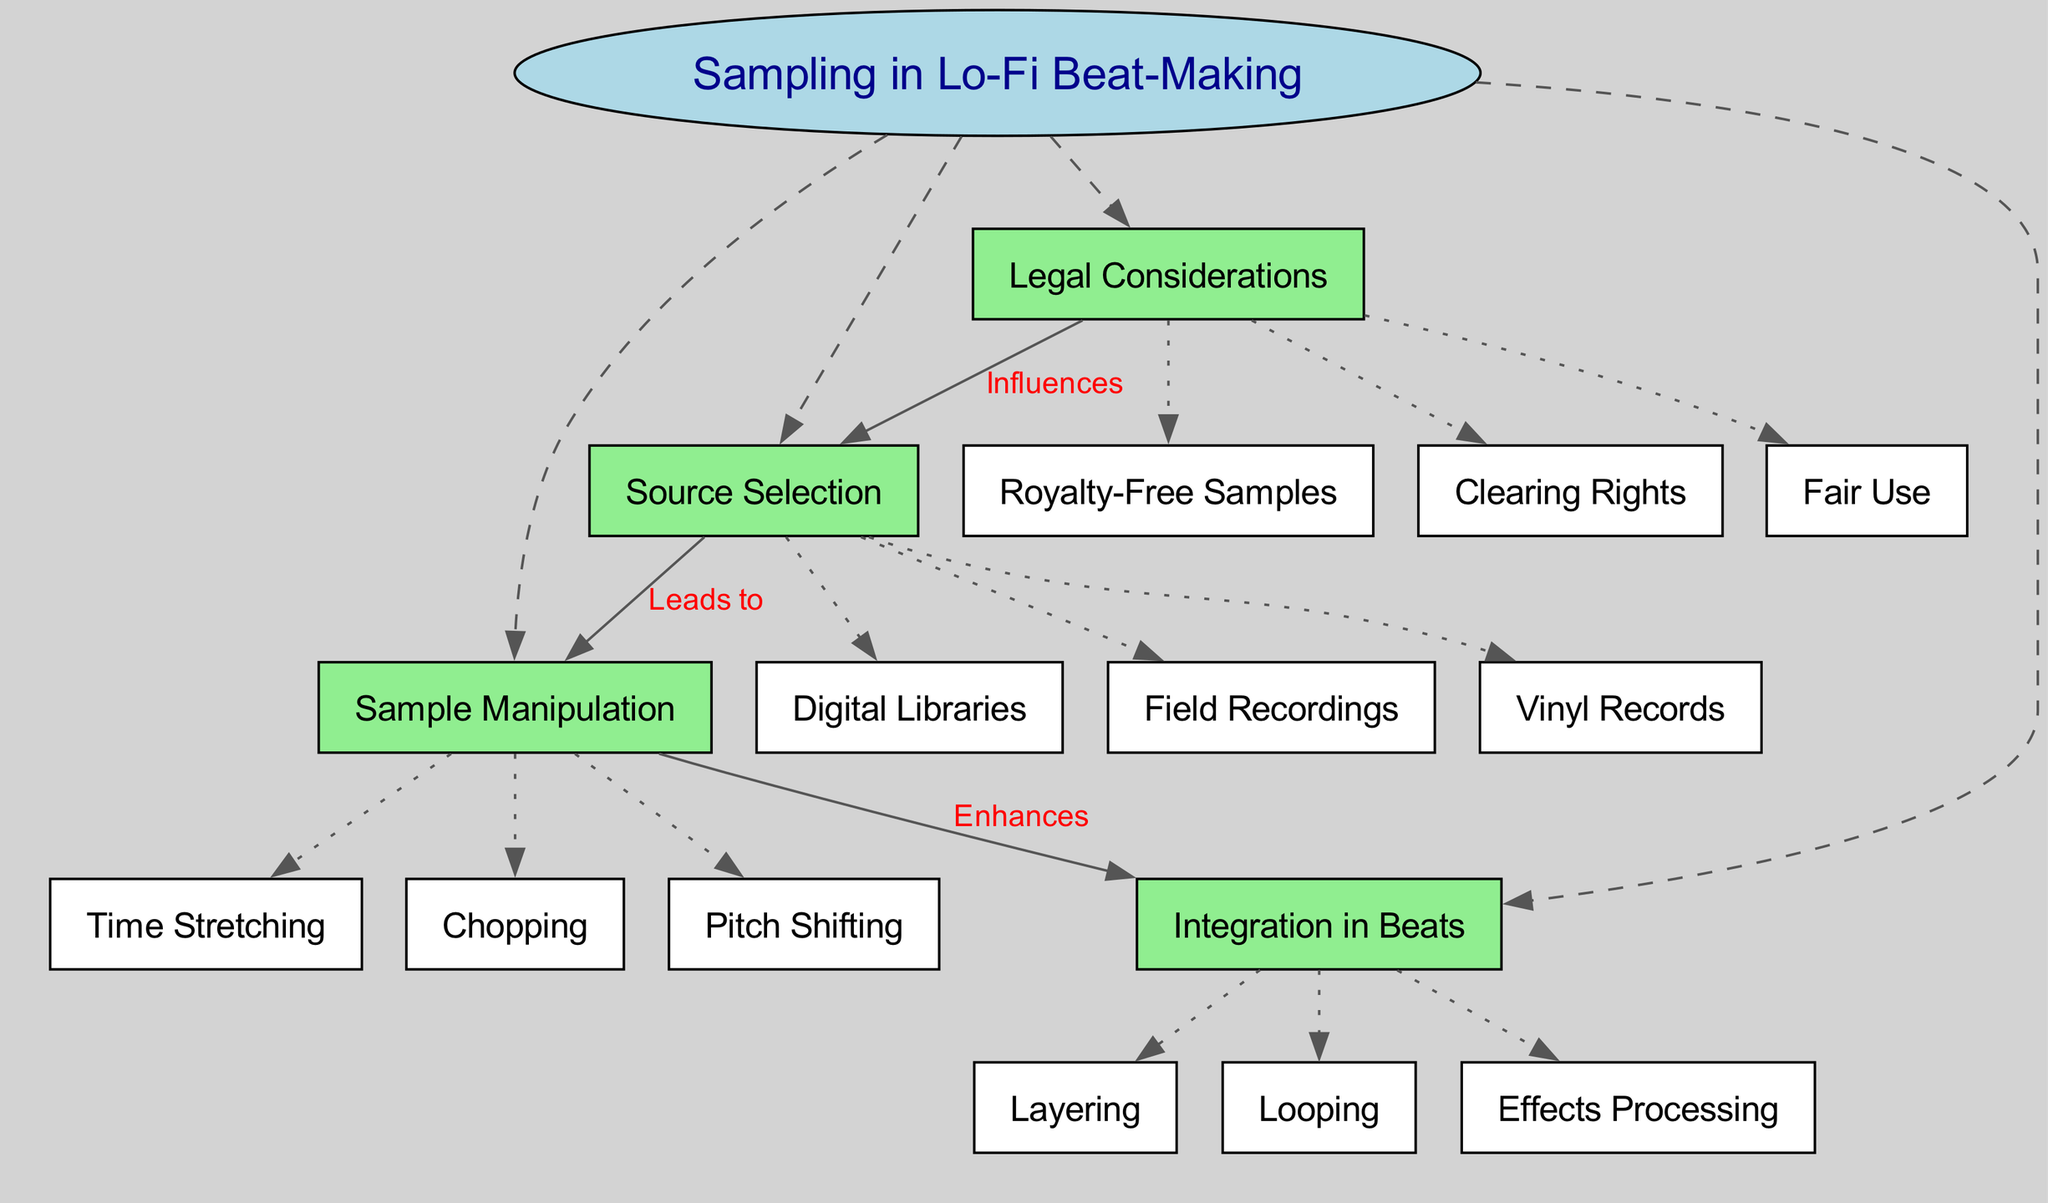What is the central concept of the diagram? The central concept is indicated at the very top of the diagram and is enclosed in an ellipse shape labeled "Sampling in Lo-Fi Beat-Making".
Answer: Sampling in Lo-Fi Beat-Making How many main nodes are there? The main nodes are defined as the highlighted green rectangles branching from the central concept. Counting these nodes shows there are four main nodes.
Answer: 4 What influences source selection? The diagram shows a connection labeled "Influences" that leads from "Legal Considerations" to "Source Selection". This indicates that legal aspects affect the choice of sources for sampling.
Answer: Legal Considerations What enhances the integration in beats? The connection labeled "Enhances" flows from "Sample Manipulation" to "Integration in Beats", suggesting that manipulation of samples plays a crucial role in how samples are incorporated into beats.
Answer: Sample Manipulation Name one type of source for sampling. The sub-node under "Source Selection" includes options listed in white rectangles. One such option is "Vinyl Records", which is a common source for sampling in lo-fi music.
Answer: Vinyl Records What are the three sub-nodes under sample manipulation? The diagram shows three sub-nodes extending from "Sample Manipulation": "Chopping", "Pitch Shifting", and "Time Stretching". These techniques are crucial for altering samples in lo-fi beat-making.
Answer: Chopping, Pitch Shifting, Time Stretching What is one method of integrating samples in beats? Looking at the sub-nodes under "Integration in Beats", "Layering" is one of the techniques used, which signifies the combination of multiple sounds.
Answer: Layering Which sub-node is connected to "Source Selection" that highlights a consideration for sampling? The sub-node "Royalty-Free Samples" reflects a significant aspect connected to the "Source Selection" node under legal considerations, pointing out the importance of rights when choosing sources.
Answer: Royalty-Free Samples How does sample manipulation contribute to beat-making? The enhancement of integration in beats through sample manipulation indicates that techniques like chopping or pitch shifting improve the overall quality and creativity of the beat, illustrating the direct benefit of manipulation on beat-making.
Answer: Enhances integration in beats 